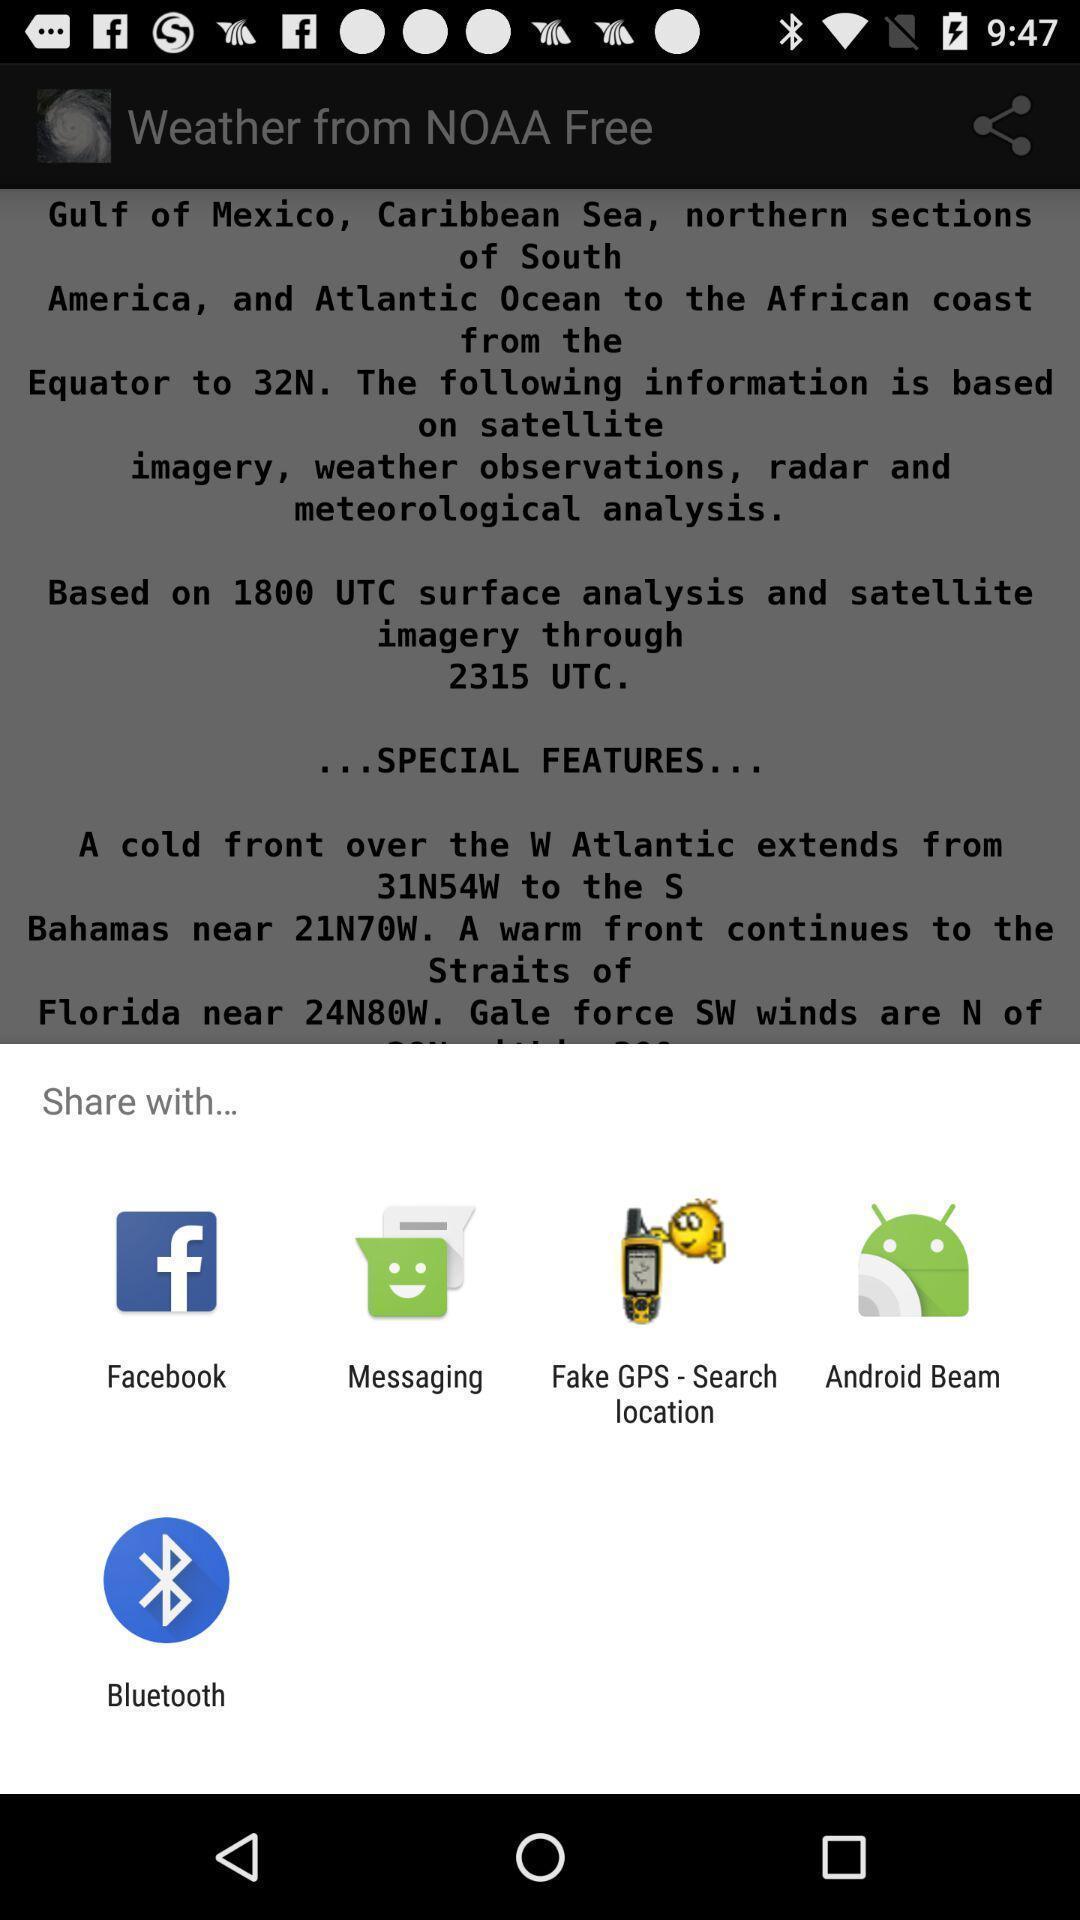Explain the elements present in this screenshot. Pop-up showing few application icons. 